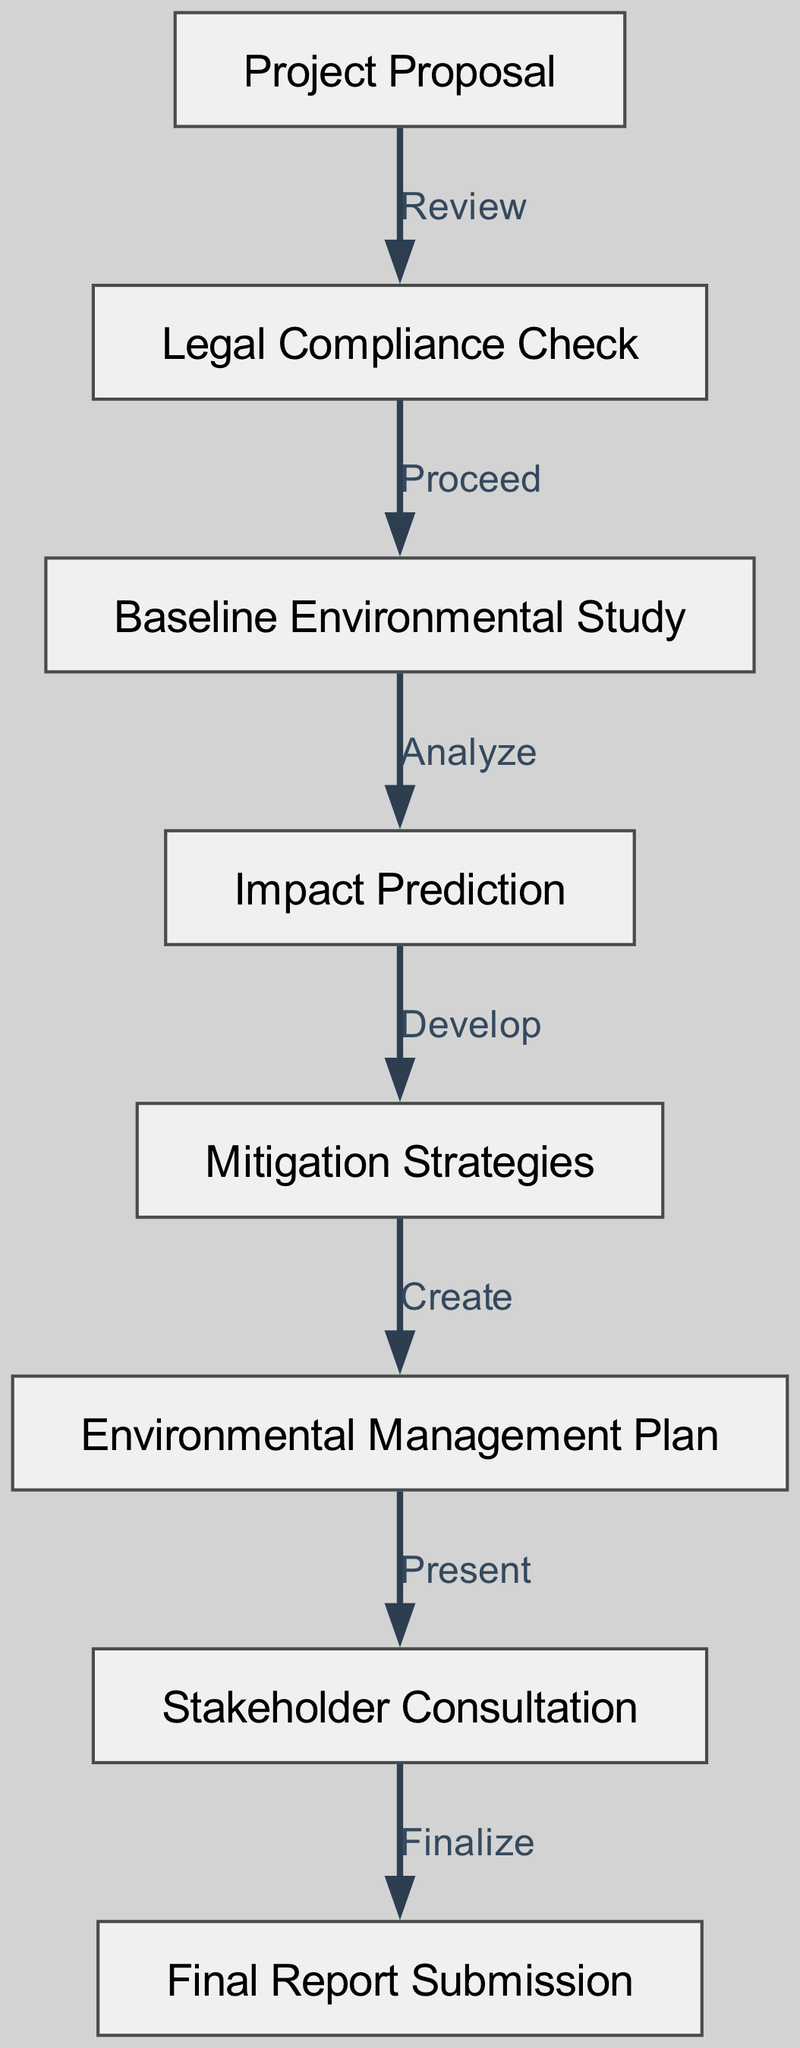What is the first step in the flowchart? The diagram starts with the node labeled "Project Proposal," which indicates it is the initial step in the process.
Answer: Project Proposal How many nodes are there in the diagram? By counting the nodes listed in the "nodes" section of the data, there are a total of eight distinct nodes in the flowchart.
Answer: 8 What action follows the "Legal Compliance Check"? The arrow from the "Legal Compliance Check" node to the "Baseline Environmental Study" node indicates that the next action after a legal compliance check is to proceed to that study.
Answer: Baseline Environmental Study Which node leads to the "Final Report Submission"? The "Stakeholder Consultation" node is the one that leads directly to the "Final Report Submission," as indicated by the edge connecting these two nodes in the flowchart.
Answer: Stakeholder Consultation How many edges are present in the diagram? By reviewing the "edges" section, we find that there are a total of seven edges connecting the various nodes, showing the flow of actions.
Answer: 7 What is the last step in the process? The flowchart culminates at the "Final Report Submission," which is the last node that concludes the various steps taken in the environmental impact assessment process.
Answer: Final Report Submission What is the relationship between "Impact Prediction" and "Mitigation Strategies"? The edge between "Impact Prediction" and "Mitigation Strategies" denotes the action of developing mitigation strategies based on the predictions of environmental impacts.
Answer: Develop Which step must come before stakeholder consultation? The "Environmental Management Plan" step is necessary before moving on to conduct stakeholder consultations, as indicated by the flow from node six to node seven.
Answer: Environmental Management Plan 